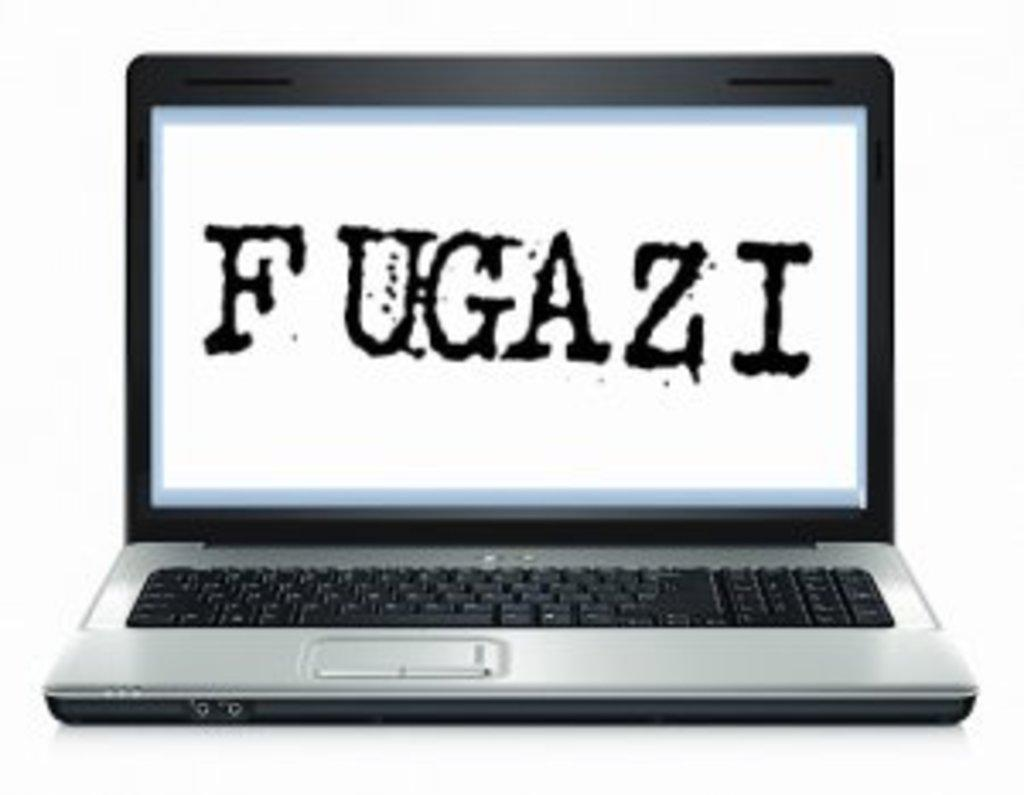<image>
Offer a succinct explanation of the picture presented. Laptop computer with keyboard saying Fugazi on the main screen. 